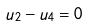Convert formula to latex. <formula><loc_0><loc_0><loc_500><loc_500>u _ { 2 } - u _ { 4 } = 0</formula> 